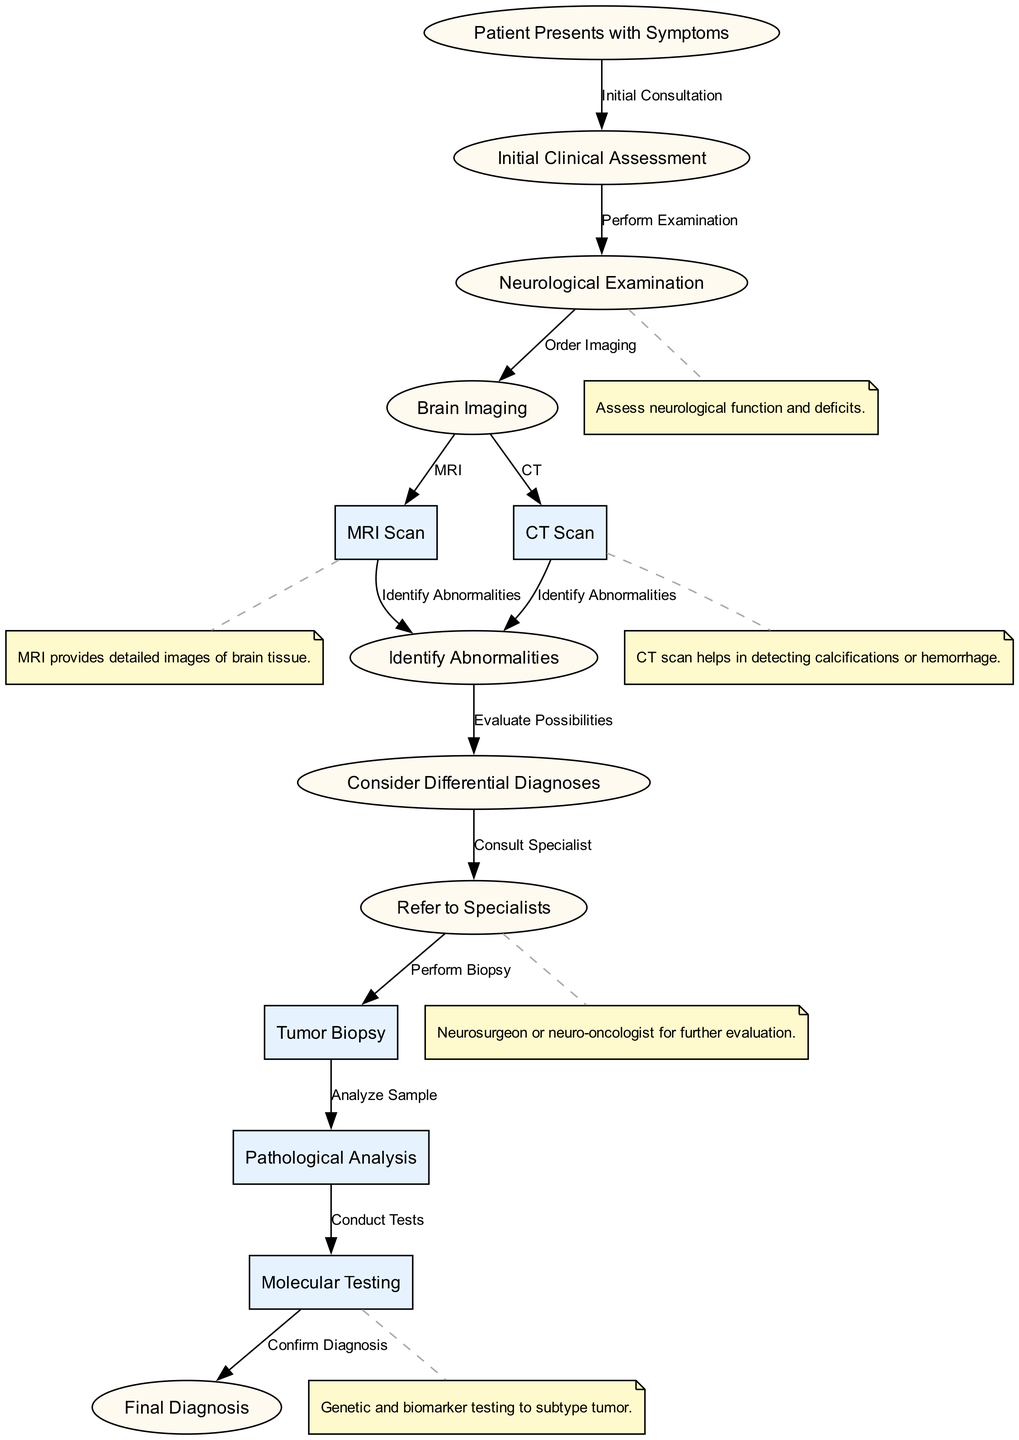What is the initial step in the diagnostic workflow? The first node in the diagram is "Patient Presents with Symptoms," indicating that this is the starting point of the diagnostic process.
Answer: Patient Presents with Symptoms How many nodes are in the diagram? Counting all the nodes listed in the diagram, there are a total of 13 distinct nodes that describe the steps in the diagnostic workflow.
Answer: 13 What is the relationship between the "Neurological Examination" and "Brain Imaging"? The diagram shows that after the "Neurological Examination," a decision is made to "Order Imaging," connecting these two nodes in a sequential manner.
Answer: Order Imaging Which imaging technique provides detailed images of brain tissue? The annotation connected to the "MRI Scan" node specifies that MRI provides detailed images of brain tissue, distinguishing it from other imaging methods.
Answer: MRI What happens after identifying abnormalities on imaging? Following the "Identify Abnormalities" step, the workflow moves to "Consider Differential Diagnoses," indicating that differential diagnosis is the next crucial step.
Answer: Consider Differential Diagnoses Who should be consulted after considering differential diagnoses? The diagram specifies to "Refer to Specialists," highlighting the role of specialists in the diagnostic pathway after evaluating possible conditions.
Answer: Refer to Specialists What is the final step in the diagnostic workflow? The last node in the diagram indicates that the "Final Diagnosis" is made after conducting molecular testing and pathological analysis, marking the conclusion of the process.
Answer: Final Diagnosis What does 'Conduct Tests' refer to in the context of the workflow? The "Conduct Tests" node links back to the "Molecular Testing" step, suggesting it refers to the molecular and biomarker tests conducted to further define the type of tumor.
Answer: Molecular Testing What type of specialist is referred to after the "Consider Differential Diagnoses" step? The diagram mentions a "Neurosurgeon or neuro-oncologist" as the type of specialist to be consulted, which is crucial for further evaluation of potential tumors.
Answer: Neurosurgeon or neuro-oncologist 